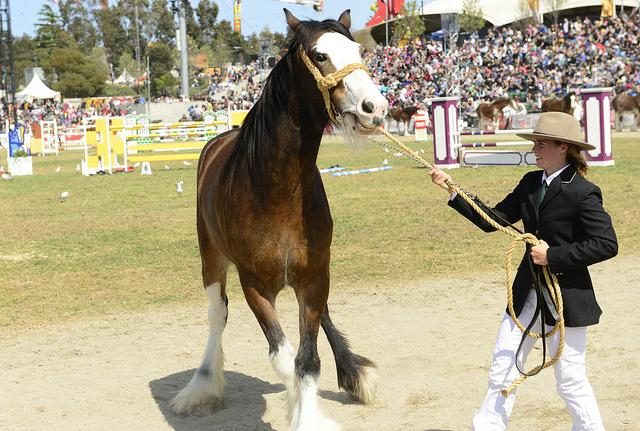What is it called when this animal moves? gallop 